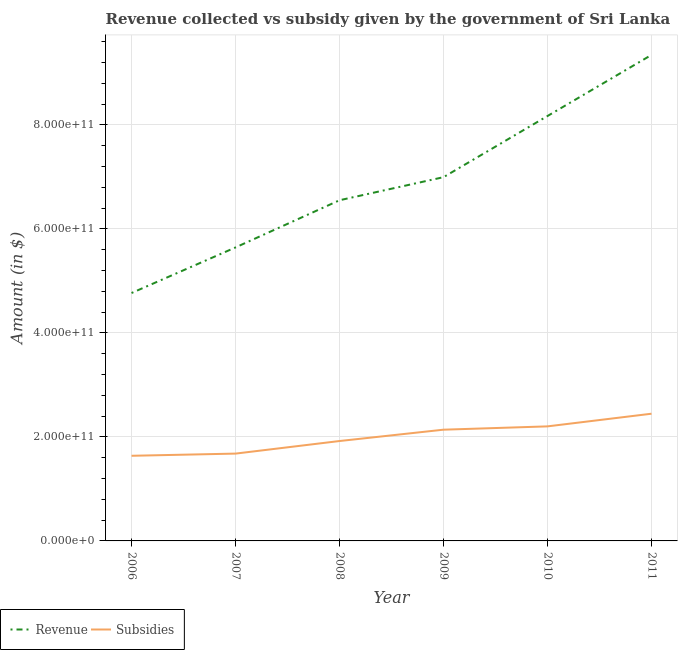How many different coloured lines are there?
Offer a terse response. 2. What is the amount of subsidies given in 2009?
Make the answer very short. 2.14e+11. Across all years, what is the maximum amount of revenue collected?
Offer a very short reply. 9.35e+11. Across all years, what is the minimum amount of subsidies given?
Your answer should be compact. 1.64e+11. In which year was the amount of subsidies given maximum?
Your answer should be compact. 2011. What is the total amount of revenue collected in the graph?
Provide a short and direct response. 4.15e+12. What is the difference between the amount of revenue collected in 2007 and that in 2008?
Your answer should be very brief. -9.08e+1. What is the difference between the amount of revenue collected in 2011 and the amount of subsidies given in 2009?
Offer a terse response. 7.21e+11. What is the average amount of subsidies given per year?
Keep it short and to the point. 2.00e+11. In the year 2006, what is the difference between the amount of revenue collected and amount of subsidies given?
Ensure brevity in your answer.  3.13e+11. What is the ratio of the amount of revenue collected in 2006 to that in 2007?
Provide a short and direct response. 0.84. Is the difference between the amount of subsidies given in 2006 and 2011 greater than the difference between the amount of revenue collected in 2006 and 2011?
Ensure brevity in your answer.  Yes. What is the difference between the highest and the second highest amount of revenue collected?
Provide a short and direct response. 1.17e+11. What is the difference between the highest and the lowest amount of revenue collected?
Give a very brief answer. 4.58e+11. In how many years, is the amount of revenue collected greater than the average amount of revenue collected taken over all years?
Keep it short and to the point. 3. Is the amount of revenue collected strictly less than the amount of subsidies given over the years?
Give a very brief answer. No. How many lines are there?
Offer a very short reply. 2. What is the difference between two consecutive major ticks on the Y-axis?
Your answer should be very brief. 2.00e+11. Where does the legend appear in the graph?
Your response must be concise. Bottom left. How are the legend labels stacked?
Your answer should be compact. Horizontal. What is the title of the graph?
Give a very brief answer. Revenue collected vs subsidy given by the government of Sri Lanka. Does "Merchandise imports" appear as one of the legend labels in the graph?
Ensure brevity in your answer.  No. What is the label or title of the X-axis?
Ensure brevity in your answer.  Year. What is the label or title of the Y-axis?
Give a very brief answer. Amount (in $). What is the Amount (in $) in Revenue in 2006?
Your answer should be compact. 4.77e+11. What is the Amount (in $) in Subsidies in 2006?
Offer a terse response. 1.64e+11. What is the Amount (in $) in Revenue in 2007?
Ensure brevity in your answer.  5.65e+11. What is the Amount (in $) of Subsidies in 2007?
Provide a succinct answer. 1.68e+11. What is the Amount (in $) in Revenue in 2008?
Offer a terse response. 6.55e+11. What is the Amount (in $) in Subsidies in 2008?
Ensure brevity in your answer.  1.92e+11. What is the Amount (in $) of Revenue in 2009?
Give a very brief answer. 7.00e+11. What is the Amount (in $) in Subsidies in 2009?
Offer a very short reply. 2.14e+11. What is the Amount (in $) in Revenue in 2010?
Offer a very short reply. 8.17e+11. What is the Amount (in $) in Subsidies in 2010?
Your response must be concise. 2.20e+11. What is the Amount (in $) in Revenue in 2011?
Offer a very short reply. 9.35e+11. What is the Amount (in $) in Subsidies in 2011?
Give a very brief answer. 2.45e+11. Across all years, what is the maximum Amount (in $) of Revenue?
Offer a very short reply. 9.35e+11. Across all years, what is the maximum Amount (in $) in Subsidies?
Your answer should be very brief. 2.45e+11. Across all years, what is the minimum Amount (in $) of Revenue?
Provide a succinct answer. 4.77e+11. Across all years, what is the minimum Amount (in $) of Subsidies?
Give a very brief answer. 1.64e+11. What is the total Amount (in $) of Revenue in the graph?
Make the answer very short. 4.15e+12. What is the total Amount (in $) in Subsidies in the graph?
Your response must be concise. 1.20e+12. What is the difference between the Amount (in $) of Revenue in 2006 and that in 2007?
Ensure brevity in your answer.  -8.77e+1. What is the difference between the Amount (in $) in Subsidies in 2006 and that in 2007?
Ensure brevity in your answer.  -4.19e+09. What is the difference between the Amount (in $) of Revenue in 2006 and that in 2008?
Offer a terse response. -1.78e+11. What is the difference between the Amount (in $) in Subsidies in 2006 and that in 2008?
Your answer should be compact. -2.84e+1. What is the difference between the Amount (in $) in Revenue in 2006 and that in 2009?
Your answer should be very brief. -2.23e+11. What is the difference between the Amount (in $) in Subsidies in 2006 and that in 2009?
Offer a very short reply. -5.02e+1. What is the difference between the Amount (in $) of Revenue in 2006 and that in 2010?
Give a very brief answer. -3.40e+11. What is the difference between the Amount (in $) of Subsidies in 2006 and that in 2010?
Give a very brief answer. -5.66e+1. What is the difference between the Amount (in $) in Revenue in 2006 and that in 2011?
Ensure brevity in your answer.  -4.58e+11. What is the difference between the Amount (in $) in Subsidies in 2006 and that in 2011?
Your answer should be compact. -8.09e+1. What is the difference between the Amount (in $) in Revenue in 2007 and that in 2008?
Give a very brief answer. -9.08e+1. What is the difference between the Amount (in $) in Subsidies in 2007 and that in 2008?
Your answer should be very brief. -2.42e+1. What is the difference between the Amount (in $) of Revenue in 2007 and that in 2009?
Keep it short and to the point. -1.35e+11. What is the difference between the Amount (in $) in Subsidies in 2007 and that in 2009?
Keep it short and to the point. -4.60e+1. What is the difference between the Amount (in $) in Revenue in 2007 and that in 2010?
Make the answer very short. -2.53e+11. What is the difference between the Amount (in $) in Subsidies in 2007 and that in 2010?
Your answer should be very brief. -5.24e+1. What is the difference between the Amount (in $) in Revenue in 2007 and that in 2011?
Your answer should be compact. -3.70e+11. What is the difference between the Amount (in $) in Subsidies in 2007 and that in 2011?
Give a very brief answer. -7.67e+1. What is the difference between the Amount (in $) in Revenue in 2008 and that in 2009?
Keep it short and to the point. -4.44e+1. What is the difference between the Amount (in $) of Subsidies in 2008 and that in 2009?
Your answer should be compact. -2.18e+1. What is the difference between the Amount (in $) of Revenue in 2008 and that in 2010?
Offer a very short reply. -1.62e+11. What is the difference between the Amount (in $) of Subsidies in 2008 and that in 2010?
Give a very brief answer. -2.82e+1. What is the difference between the Amount (in $) in Revenue in 2008 and that in 2011?
Ensure brevity in your answer.  -2.80e+11. What is the difference between the Amount (in $) of Subsidies in 2008 and that in 2011?
Your answer should be compact. -5.25e+1. What is the difference between the Amount (in $) of Revenue in 2009 and that in 2010?
Your response must be concise. -1.18e+11. What is the difference between the Amount (in $) of Subsidies in 2009 and that in 2010?
Ensure brevity in your answer.  -6.37e+09. What is the difference between the Amount (in $) of Revenue in 2009 and that in 2011?
Give a very brief answer. -2.35e+11. What is the difference between the Amount (in $) of Subsidies in 2009 and that in 2011?
Offer a very short reply. -3.07e+1. What is the difference between the Amount (in $) in Revenue in 2010 and that in 2011?
Make the answer very short. -1.17e+11. What is the difference between the Amount (in $) in Subsidies in 2010 and that in 2011?
Offer a terse response. -2.44e+1. What is the difference between the Amount (in $) in Revenue in 2006 and the Amount (in $) in Subsidies in 2007?
Provide a succinct answer. 3.09e+11. What is the difference between the Amount (in $) of Revenue in 2006 and the Amount (in $) of Subsidies in 2008?
Provide a succinct answer. 2.85e+11. What is the difference between the Amount (in $) of Revenue in 2006 and the Amount (in $) of Subsidies in 2009?
Keep it short and to the point. 2.63e+11. What is the difference between the Amount (in $) of Revenue in 2006 and the Amount (in $) of Subsidies in 2010?
Your answer should be very brief. 2.57e+11. What is the difference between the Amount (in $) in Revenue in 2006 and the Amount (in $) in Subsidies in 2011?
Your answer should be very brief. 2.32e+11. What is the difference between the Amount (in $) of Revenue in 2007 and the Amount (in $) of Subsidies in 2008?
Ensure brevity in your answer.  3.72e+11. What is the difference between the Amount (in $) in Revenue in 2007 and the Amount (in $) in Subsidies in 2009?
Provide a succinct answer. 3.51e+11. What is the difference between the Amount (in $) of Revenue in 2007 and the Amount (in $) of Subsidies in 2010?
Ensure brevity in your answer.  3.44e+11. What is the difference between the Amount (in $) of Revenue in 2007 and the Amount (in $) of Subsidies in 2011?
Keep it short and to the point. 3.20e+11. What is the difference between the Amount (in $) in Revenue in 2008 and the Amount (in $) in Subsidies in 2009?
Your answer should be very brief. 4.41e+11. What is the difference between the Amount (in $) of Revenue in 2008 and the Amount (in $) of Subsidies in 2010?
Make the answer very short. 4.35e+11. What is the difference between the Amount (in $) of Revenue in 2008 and the Amount (in $) of Subsidies in 2011?
Give a very brief answer. 4.11e+11. What is the difference between the Amount (in $) of Revenue in 2009 and the Amount (in $) of Subsidies in 2010?
Ensure brevity in your answer.  4.79e+11. What is the difference between the Amount (in $) in Revenue in 2009 and the Amount (in $) in Subsidies in 2011?
Your answer should be compact. 4.55e+11. What is the difference between the Amount (in $) in Revenue in 2010 and the Amount (in $) in Subsidies in 2011?
Keep it short and to the point. 5.73e+11. What is the average Amount (in $) in Revenue per year?
Provide a succinct answer. 6.91e+11. What is the average Amount (in $) in Subsidies per year?
Your answer should be compact. 2.00e+11. In the year 2006, what is the difference between the Amount (in $) in Revenue and Amount (in $) in Subsidies?
Provide a succinct answer. 3.13e+11. In the year 2007, what is the difference between the Amount (in $) in Revenue and Amount (in $) in Subsidies?
Make the answer very short. 3.97e+11. In the year 2008, what is the difference between the Amount (in $) of Revenue and Amount (in $) of Subsidies?
Provide a succinct answer. 4.63e+11. In the year 2009, what is the difference between the Amount (in $) in Revenue and Amount (in $) in Subsidies?
Keep it short and to the point. 4.86e+11. In the year 2010, what is the difference between the Amount (in $) of Revenue and Amount (in $) of Subsidies?
Offer a terse response. 5.97e+11. In the year 2011, what is the difference between the Amount (in $) in Revenue and Amount (in $) in Subsidies?
Provide a succinct answer. 6.90e+11. What is the ratio of the Amount (in $) of Revenue in 2006 to that in 2007?
Give a very brief answer. 0.84. What is the ratio of the Amount (in $) of Subsidies in 2006 to that in 2007?
Your answer should be compact. 0.98. What is the ratio of the Amount (in $) of Revenue in 2006 to that in 2008?
Provide a short and direct response. 0.73. What is the ratio of the Amount (in $) in Subsidies in 2006 to that in 2008?
Ensure brevity in your answer.  0.85. What is the ratio of the Amount (in $) of Revenue in 2006 to that in 2009?
Give a very brief answer. 0.68. What is the ratio of the Amount (in $) in Subsidies in 2006 to that in 2009?
Make the answer very short. 0.77. What is the ratio of the Amount (in $) of Revenue in 2006 to that in 2010?
Your answer should be compact. 0.58. What is the ratio of the Amount (in $) in Subsidies in 2006 to that in 2010?
Your response must be concise. 0.74. What is the ratio of the Amount (in $) in Revenue in 2006 to that in 2011?
Your answer should be very brief. 0.51. What is the ratio of the Amount (in $) in Subsidies in 2006 to that in 2011?
Provide a short and direct response. 0.67. What is the ratio of the Amount (in $) of Revenue in 2007 to that in 2008?
Your response must be concise. 0.86. What is the ratio of the Amount (in $) in Subsidies in 2007 to that in 2008?
Give a very brief answer. 0.87. What is the ratio of the Amount (in $) of Revenue in 2007 to that in 2009?
Provide a short and direct response. 0.81. What is the ratio of the Amount (in $) of Subsidies in 2007 to that in 2009?
Offer a very short reply. 0.79. What is the ratio of the Amount (in $) in Revenue in 2007 to that in 2010?
Offer a terse response. 0.69. What is the ratio of the Amount (in $) in Subsidies in 2007 to that in 2010?
Your response must be concise. 0.76. What is the ratio of the Amount (in $) of Revenue in 2007 to that in 2011?
Offer a very short reply. 0.6. What is the ratio of the Amount (in $) of Subsidies in 2007 to that in 2011?
Keep it short and to the point. 0.69. What is the ratio of the Amount (in $) in Revenue in 2008 to that in 2009?
Ensure brevity in your answer.  0.94. What is the ratio of the Amount (in $) in Subsidies in 2008 to that in 2009?
Ensure brevity in your answer.  0.9. What is the ratio of the Amount (in $) in Revenue in 2008 to that in 2010?
Ensure brevity in your answer.  0.8. What is the ratio of the Amount (in $) of Subsidies in 2008 to that in 2010?
Your answer should be very brief. 0.87. What is the ratio of the Amount (in $) in Revenue in 2008 to that in 2011?
Provide a succinct answer. 0.7. What is the ratio of the Amount (in $) in Subsidies in 2008 to that in 2011?
Offer a very short reply. 0.79. What is the ratio of the Amount (in $) in Revenue in 2009 to that in 2010?
Give a very brief answer. 0.86. What is the ratio of the Amount (in $) in Subsidies in 2009 to that in 2010?
Give a very brief answer. 0.97. What is the ratio of the Amount (in $) of Revenue in 2009 to that in 2011?
Provide a succinct answer. 0.75. What is the ratio of the Amount (in $) in Subsidies in 2009 to that in 2011?
Make the answer very short. 0.87. What is the ratio of the Amount (in $) in Revenue in 2010 to that in 2011?
Make the answer very short. 0.87. What is the ratio of the Amount (in $) in Subsidies in 2010 to that in 2011?
Your answer should be compact. 0.9. What is the difference between the highest and the second highest Amount (in $) of Revenue?
Provide a short and direct response. 1.17e+11. What is the difference between the highest and the second highest Amount (in $) of Subsidies?
Ensure brevity in your answer.  2.44e+1. What is the difference between the highest and the lowest Amount (in $) of Revenue?
Provide a succinct answer. 4.58e+11. What is the difference between the highest and the lowest Amount (in $) of Subsidies?
Provide a short and direct response. 8.09e+1. 